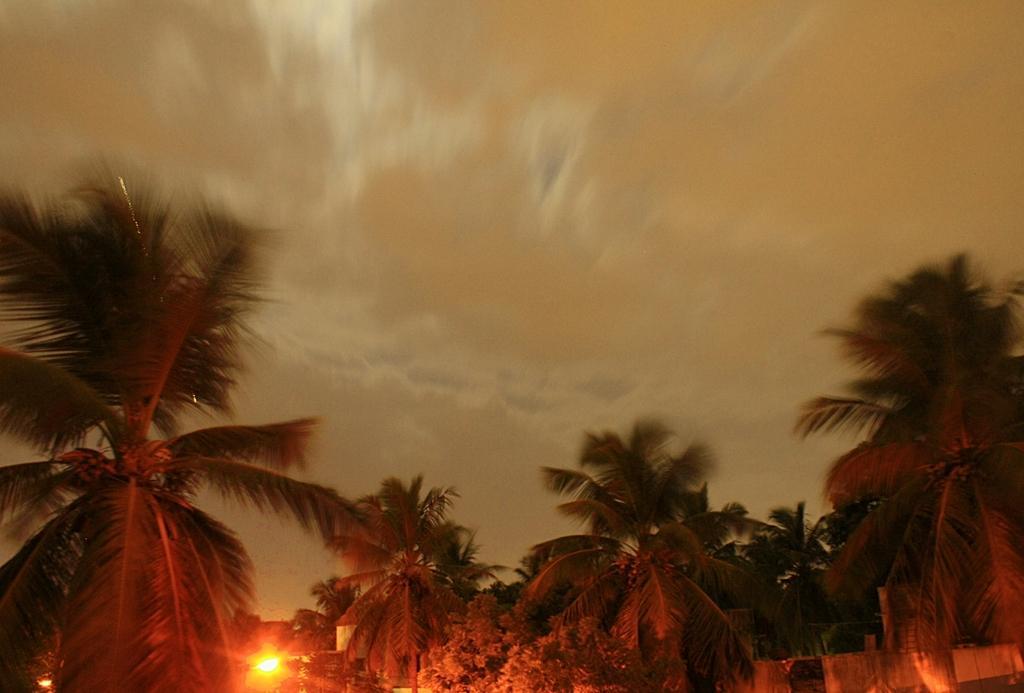Please provide a concise description of this image. In this image I can see trees. There are lights and in the background there is sky. 